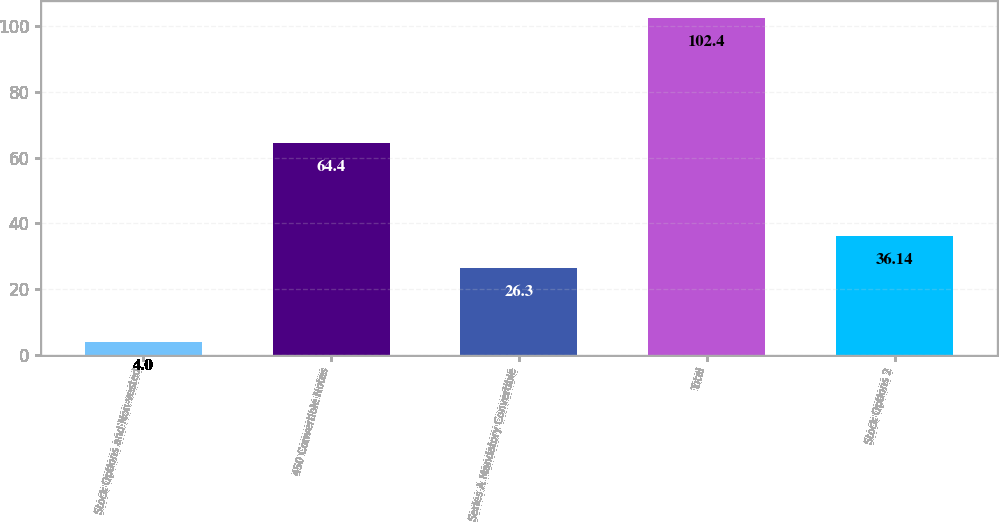<chart> <loc_0><loc_0><loc_500><loc_500><bar_chart><fcel>Stock Options and Non-vested<fcel>450 Convertible Notes<fcel>Series A Mandatory Convertible<fcel>Total<fcel>Stock Options 2<nl><fcel>4<fcel>64.4<fcel>26.3<fcel>102.4<fcel>36.14<nl></chart> 